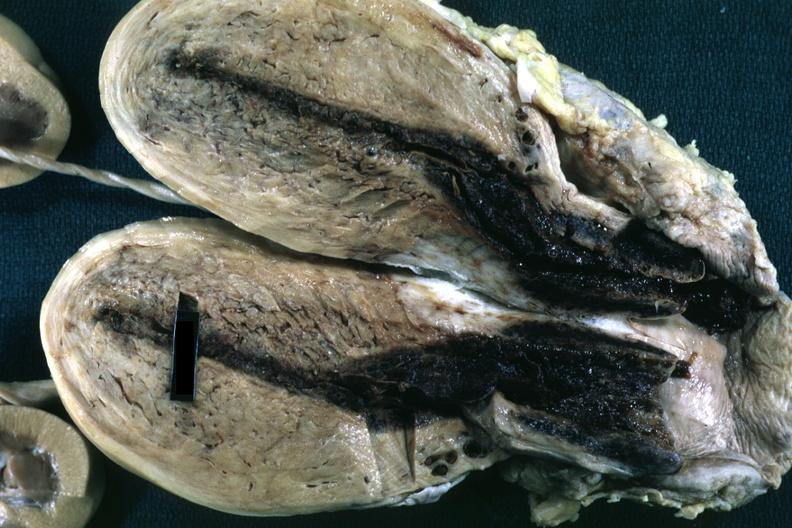what opened uterus with blood clot in cervical canal and small endometrial cavity?
Answer the question using a single word or phrase. Fixed tissue 